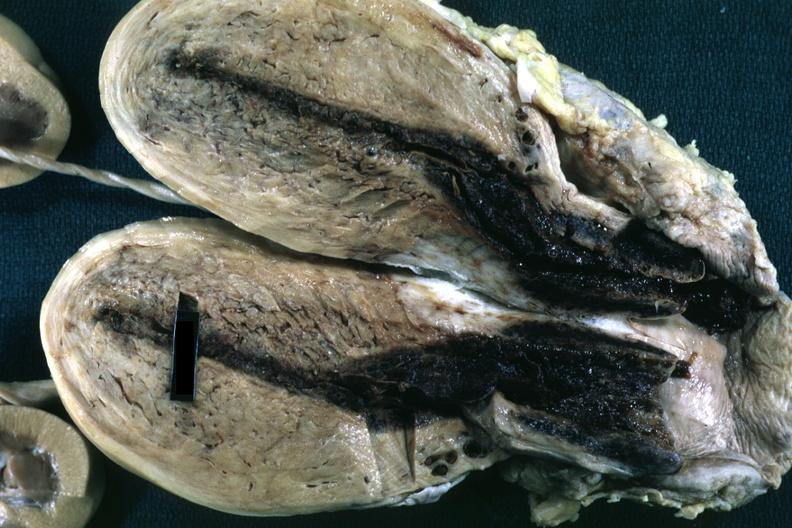what opened uterus with blood clot in cervical canal and small endometrial cavity?
Answer the question using a single word or phrase. Fixed tissue 